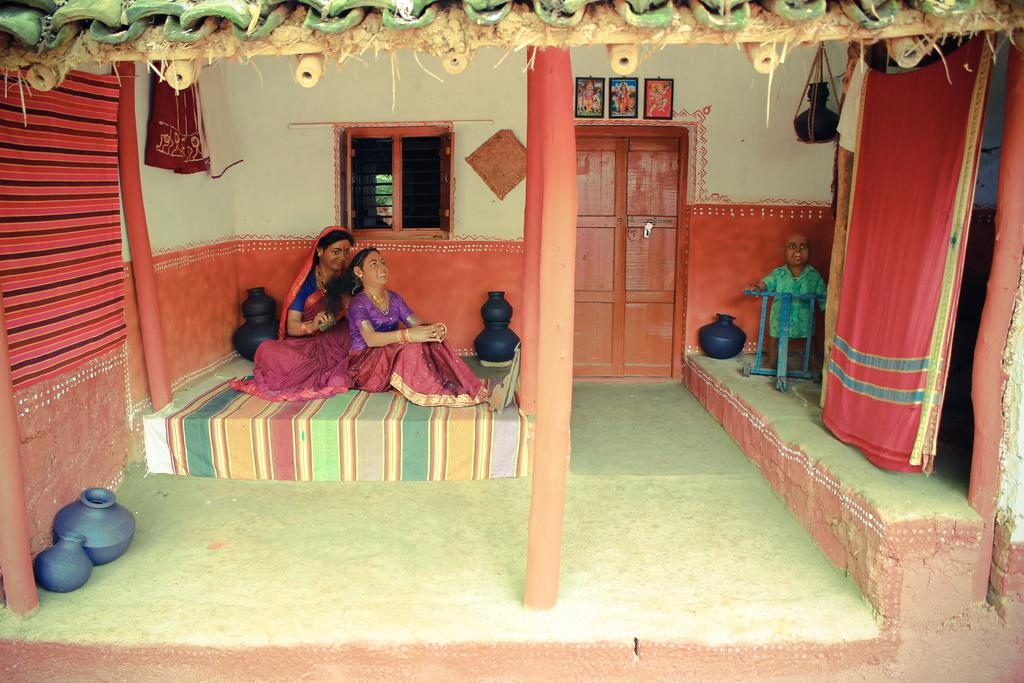What can be seen on the left side of the image? There are two sculptures on the left side of the image. What is present on the right side of the image? There is a sculpture, saree, and pot on the right side of the image. What architectural features are visible in the background of the image? There is a door and a window in the background of the image. What type of decorative items can be seen in the background of the image? There are photo frames in the background of the image. What type of straw is used to copy the sculpture on the right side of the image? There is no straw or copying activity present in the image. The image features sculptures, a saree, a pot, a door, a window, and photo frames. 